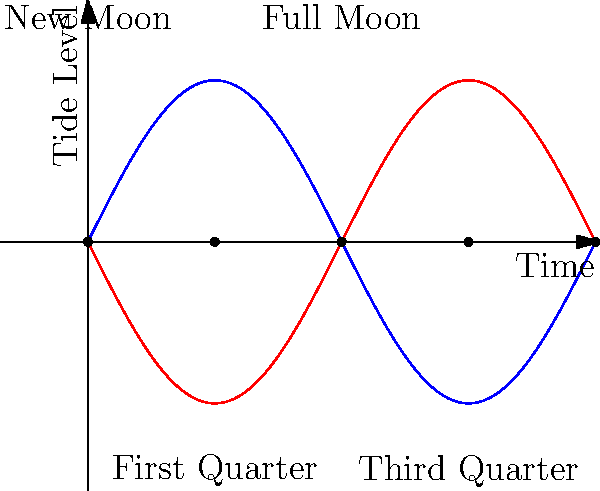As a soil scientist studying water retention, understanding tidal patterns is crucial. The graph shows tide levels over time in relation to lunar phases. Which lunar phase corresponds to the highest tidal range, and how does this relate to the gravitational forces at play? To answer this question, let's break down the relationship between lunar phases and tides:

1. Tidal forces are primarily caused by the gravitational pull of the Moon and, to a lesser extent, the Sun.

2. The graph shows tide levels over time, with the lunar phases marked.

3. The blue curve represents high tides, while the red curve represents low tides.

4. The tidal range is the difference between high and low tides.

5. Observing the graph, we can see that the tidal range is largest during Full Moon and New Moon phases.

6. This occurs because during these phases, the Sun, Earth, and Moon are aligned (syzygy), causing their gravitational forces to combine.

7. During Full and New Moons, we experience "spring tides," which have the largest tidal range.

8. Conversely, during First and Third Quarter phases, the Sun and Moon are at right angles to Earth, partially canceling out each other's gravitational effects.

9. This results in "neap tides," which have the smallest tidal range.

10. The highest tidal range corresponds to the Full and New Moon phases due to the additive effect of the Sun and Moon's gravitational forces.

For a soil scientist, this information is relevant because extreme high tides can lead to soil saturation and potential erosion in coastal areas, while extreme low tides can expose usually submerged soils, affecting their composition and water retention properties.
Answer: Full and New Moon phases; aligned gravitational forces of Sun and Moon 